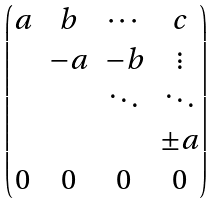Convert formula to latex. <formula><loc_0><loc_0><loc_500><loc_500>\begin{pmatrix} a & b & \cdots & c \\ & - a & - b & \vdots \\ & & \ddots & \ddots \\ & & & \pm a \\ 0 & 0 & 0 & 0 \end{pmatrix}</formula> 